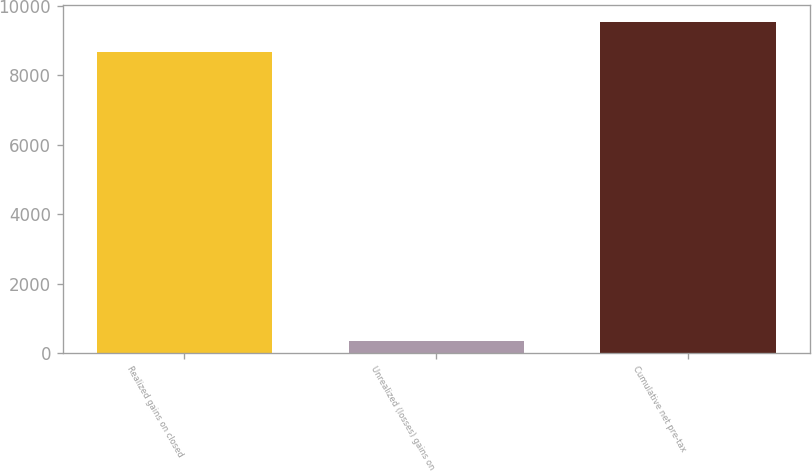Convert chart to OTSL. <chart><loc_0><loc_0><loc_500><loc_500><bar_chart><fcel>Realized gains on closed<fcel>Unrealized (losses) gains on<fcel>Cumulative net pre-tax<nl><fcel>8666<fcel>361<fcel>9532.6<nl></chart> 